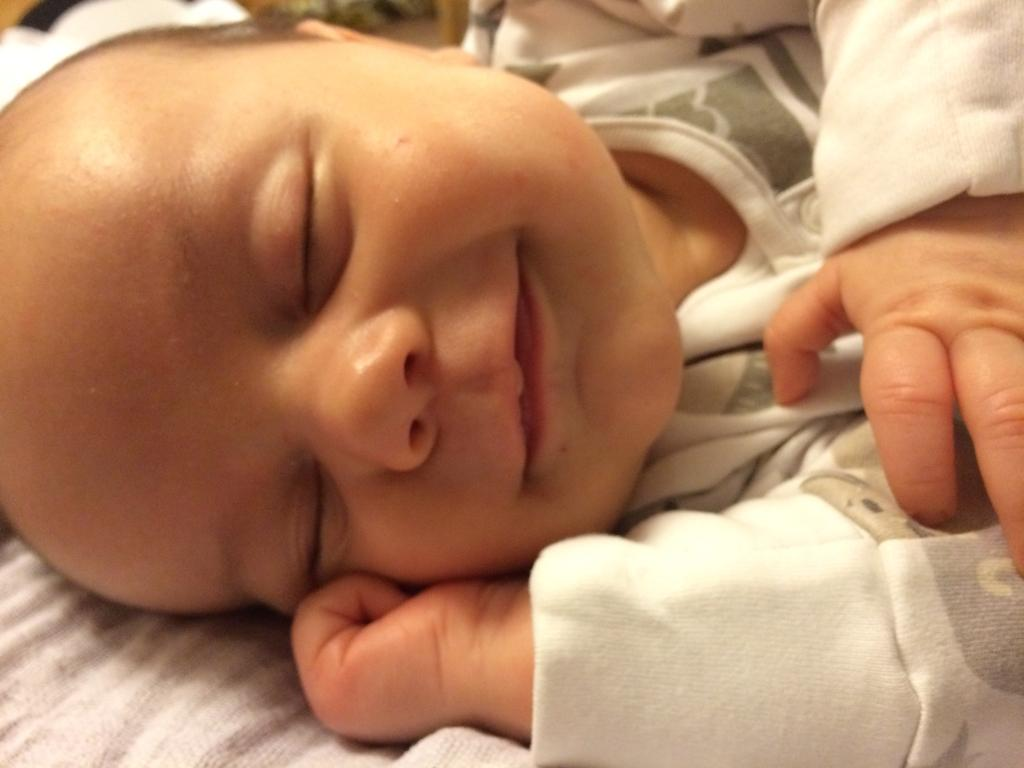What is the main subject of the image? The main subject of the image is a kid sleeping. What can be seen at the bottom of the image? There is a cloth at the bottom of the image. What type of horn can be seen on the scarecrow in the image? There is no scarecrow or horn present in the image; it features a kid sleeping and a cloth at the bottom. 